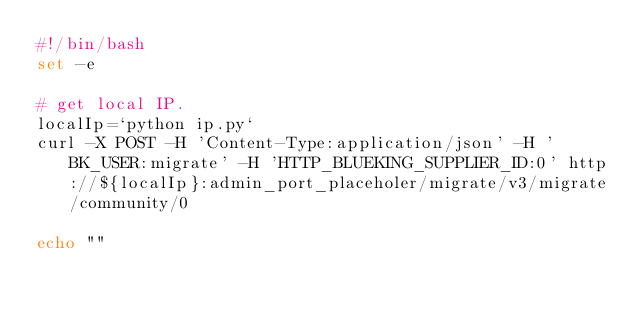<code> <loc_0><loc_0><loc_500><loc_500><_Bash_>#!/bin/bash
set -e

# get local IP.
localIp=`python ip.py`
curl -X POST -H 'Content-Type:application/json' -H 'BK_USER:migrate' -H 'HTTP_BLUEKING_SUPPLIER_ID:0' http://${localIp}:admin_port_placeholer/migrate/v3/migrate/community/0

echo ""
</code> 